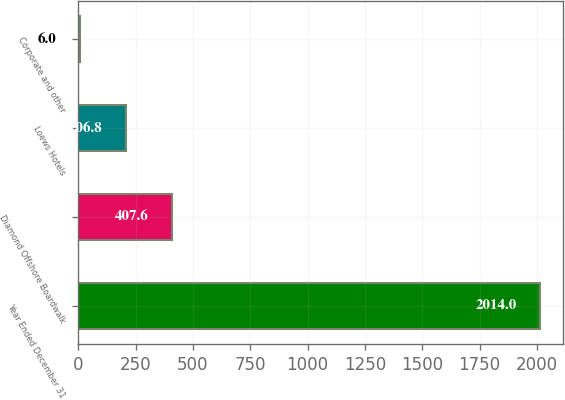<chart> <loc_0><loc_0><loc_500><loc_500><bar_chart><fcel>Year Ended December 31<fcel>Diamond Offshore Boardwalk<fcel>Loews Hotels<fcel>Corporate and other<nl><fcel>2014<fcel>407.6<fcel>206.8<fcel>6<nl></chart> 